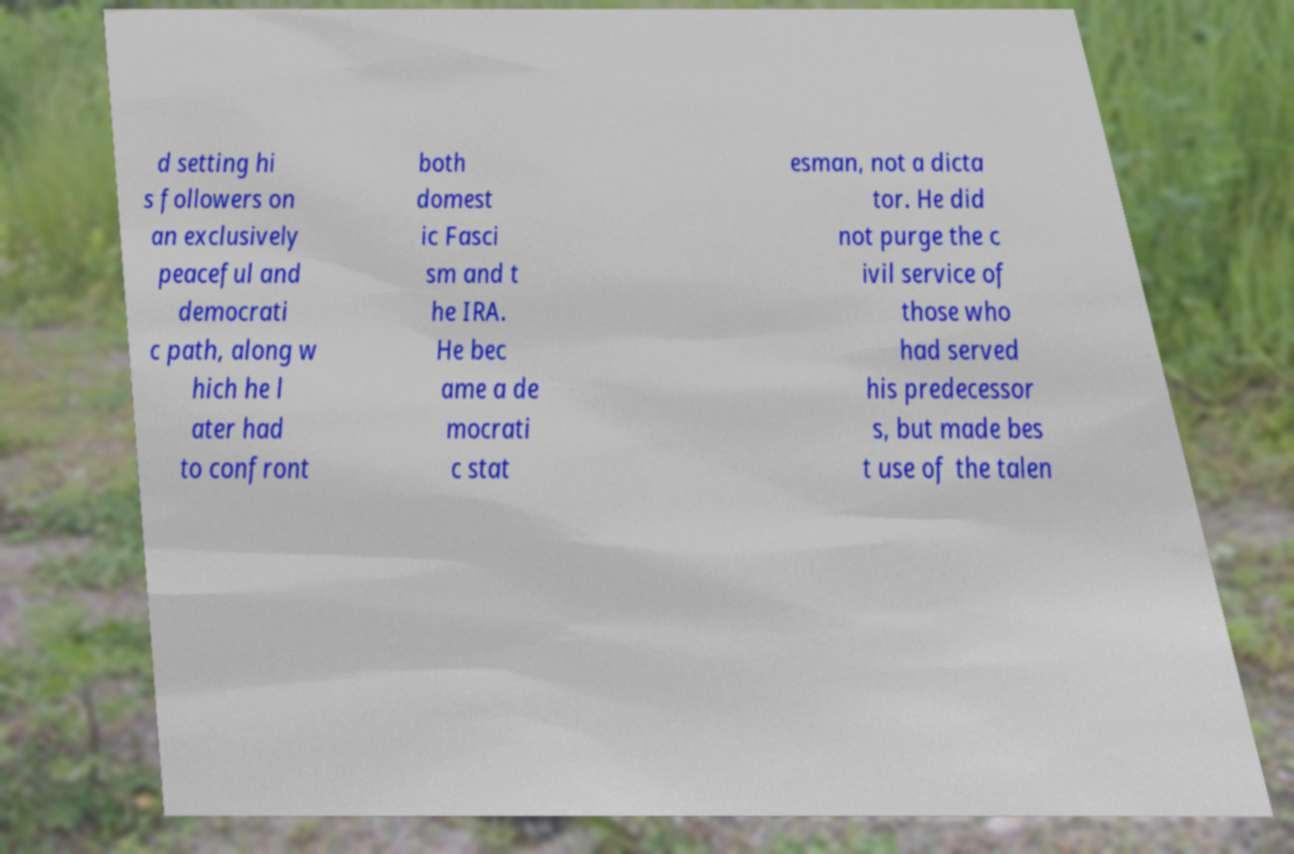I need the written content from this picture converted into text. Can you do that? d setting hi s followers on an exclusively peaceful and democrati c path, along w hich he l ater had to confront both domest ic Fasci sm and t he IRA. He bec ame a de mocrati c stat esman, not a dicta tor. He did not purge the c ivil service of those who had served his predecessor s, but made bes t use of the talen 